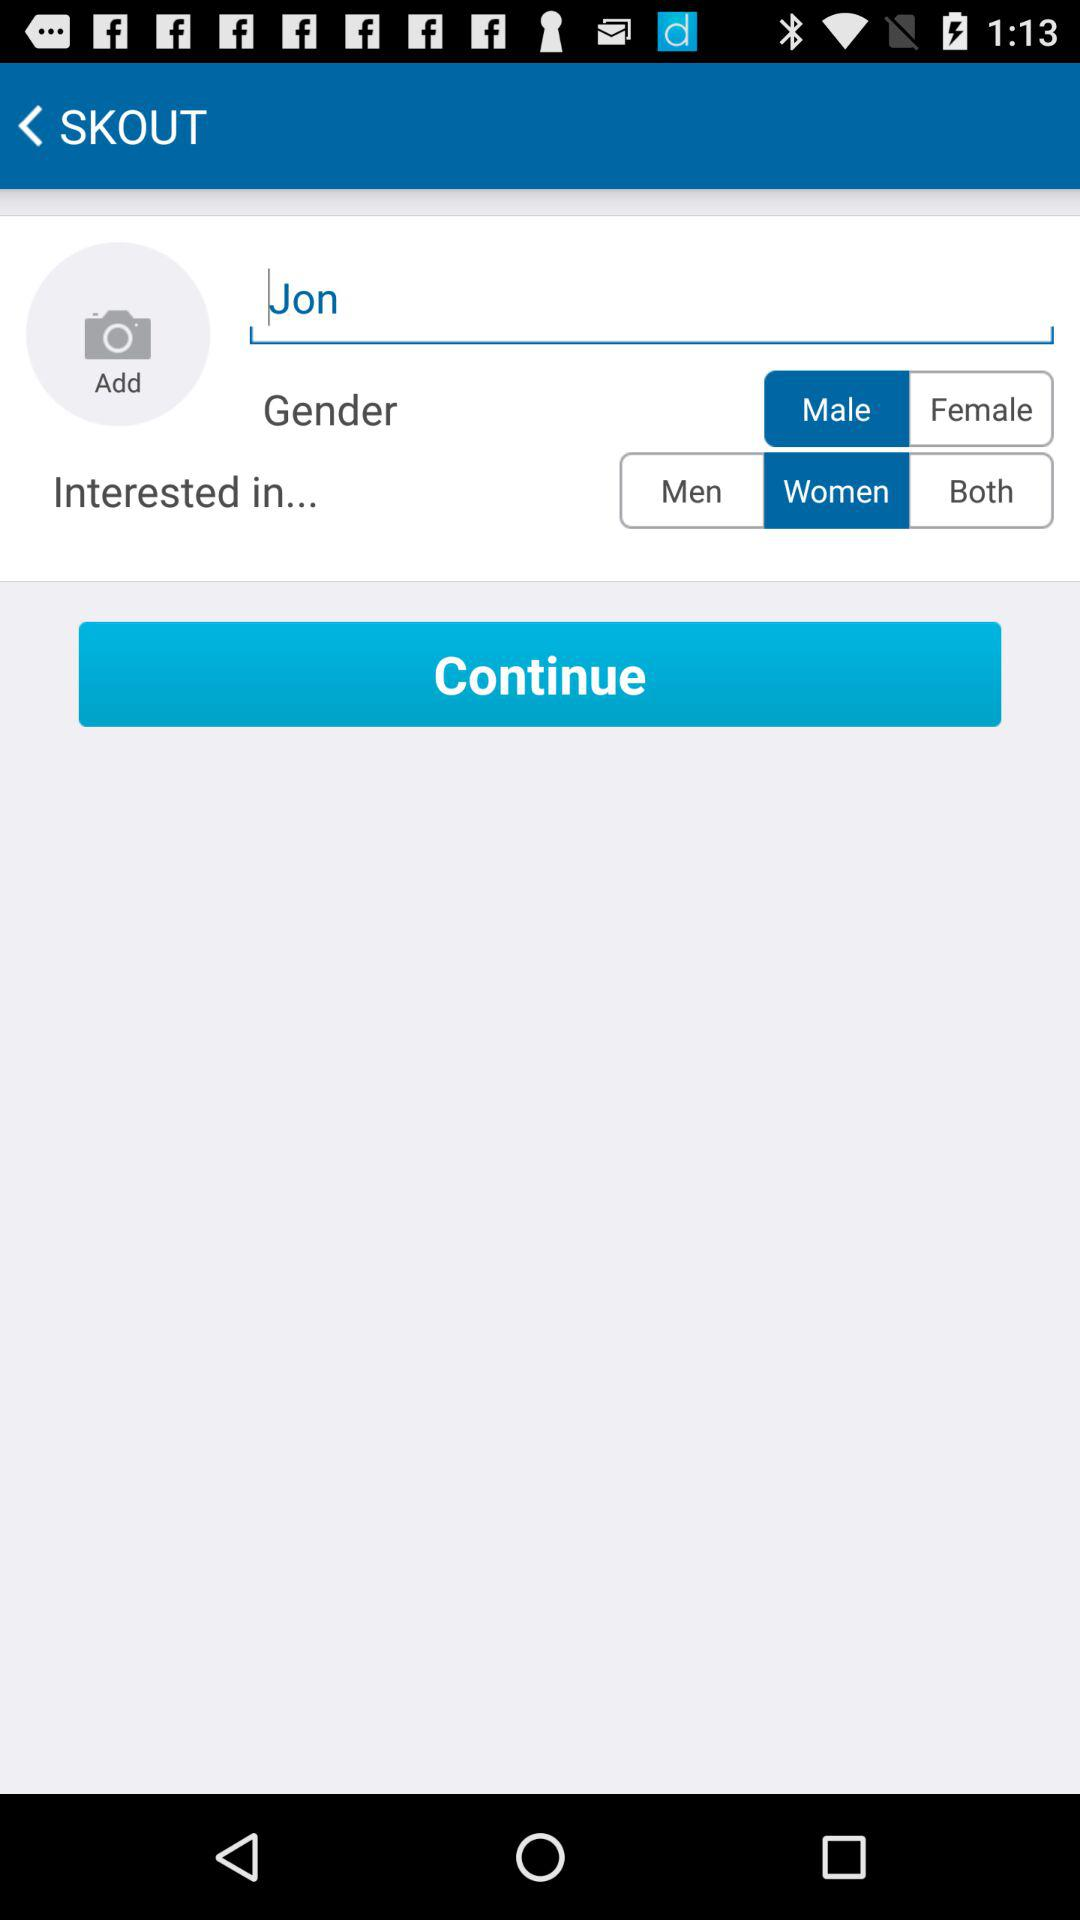Which gender is highlighted? The highlighted gender is male. 